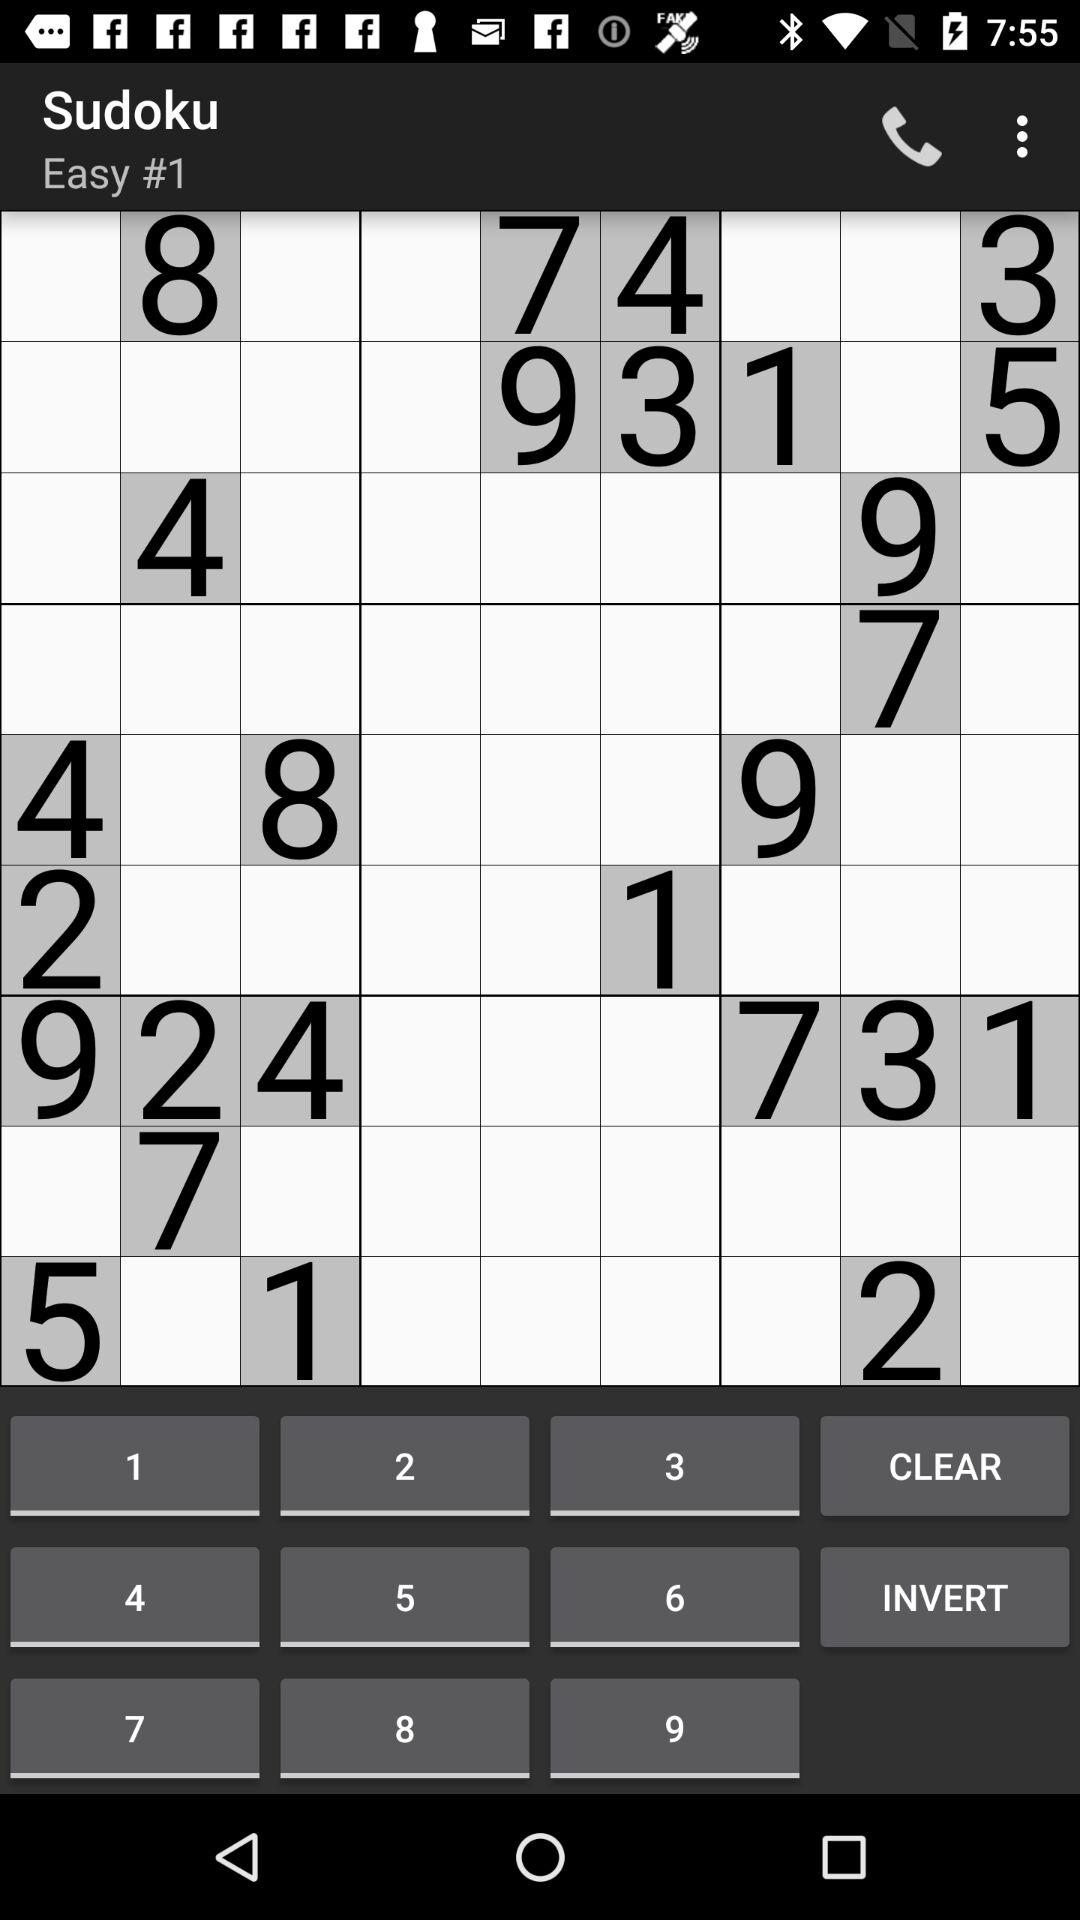What is the name of the game? The name of the game is "Sudoku". 